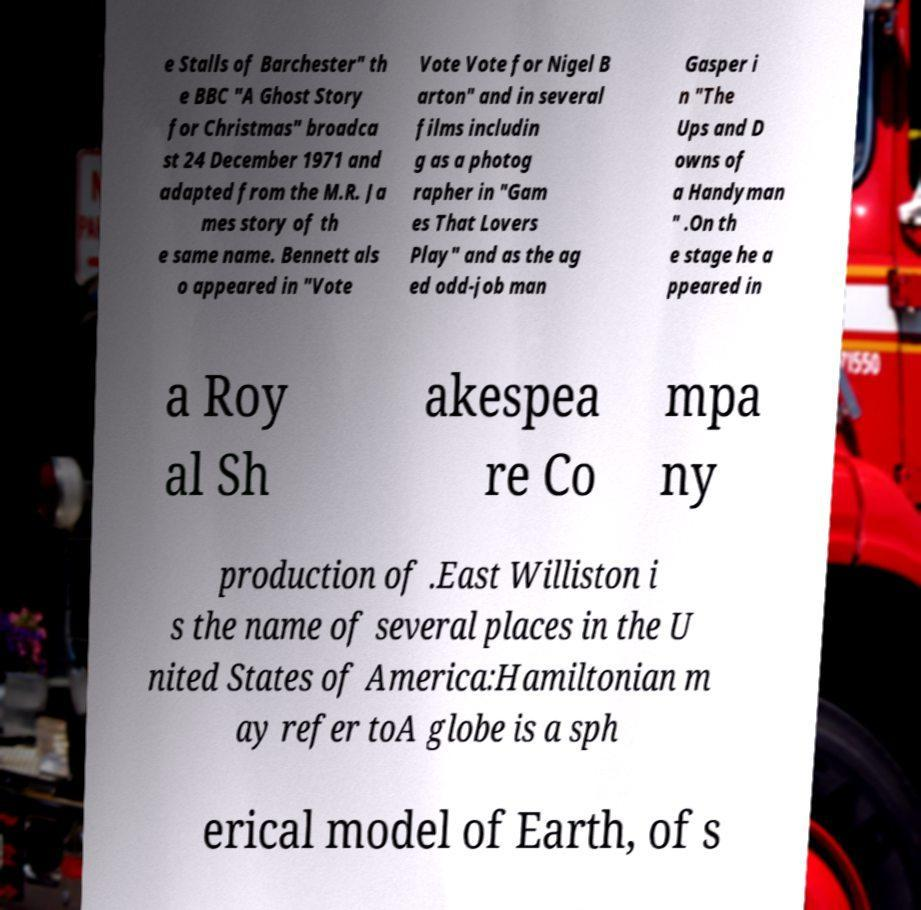Could you assist in decoding the text presented in this image and type it out clearly? e Stalls of Barchester" th e BBC "A Ghost Story for Christmas" broadca st 24 December 1971 and adapted from the M.R. Ja mes story of th e same name. Bennett als o appeared in "Vote Vote Vote for Nigel B arton" and in several films includin g as a photog rapher in "Gam es That Lovers Play" and as the ag ed odd-job man Gasper i n "The Ups and D owns of a Handyman " .On th e stage he a ppeared in a Roy al Sh akespea re Co mpa ny production of .East Williston i s the name of several places in the U nited States of America:Hamiltonian m ay refer toA globe is a sph erical model of Earth, of s 